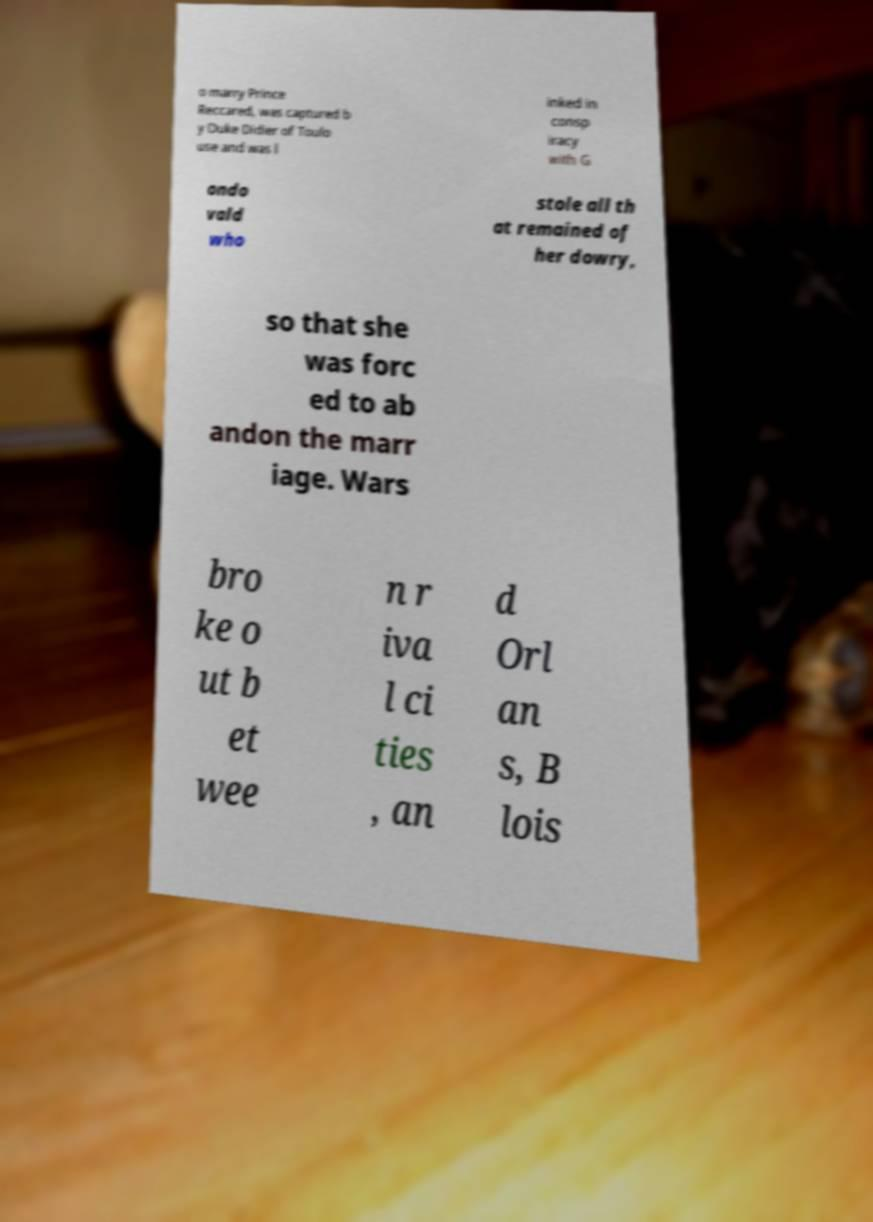Can you accurately transcribe the text from the provided image for me? o marry Prince Reccared, was captured b y Duke Didier of Toulo use and was l inked in consp iracy with G ondo vald who stole all th at remained of her dowry, so that she was forc ed to ab andon the marr iage. Wars bro ke o ut b et wee n r iva l ci ties , an d Orl an s, B lois 